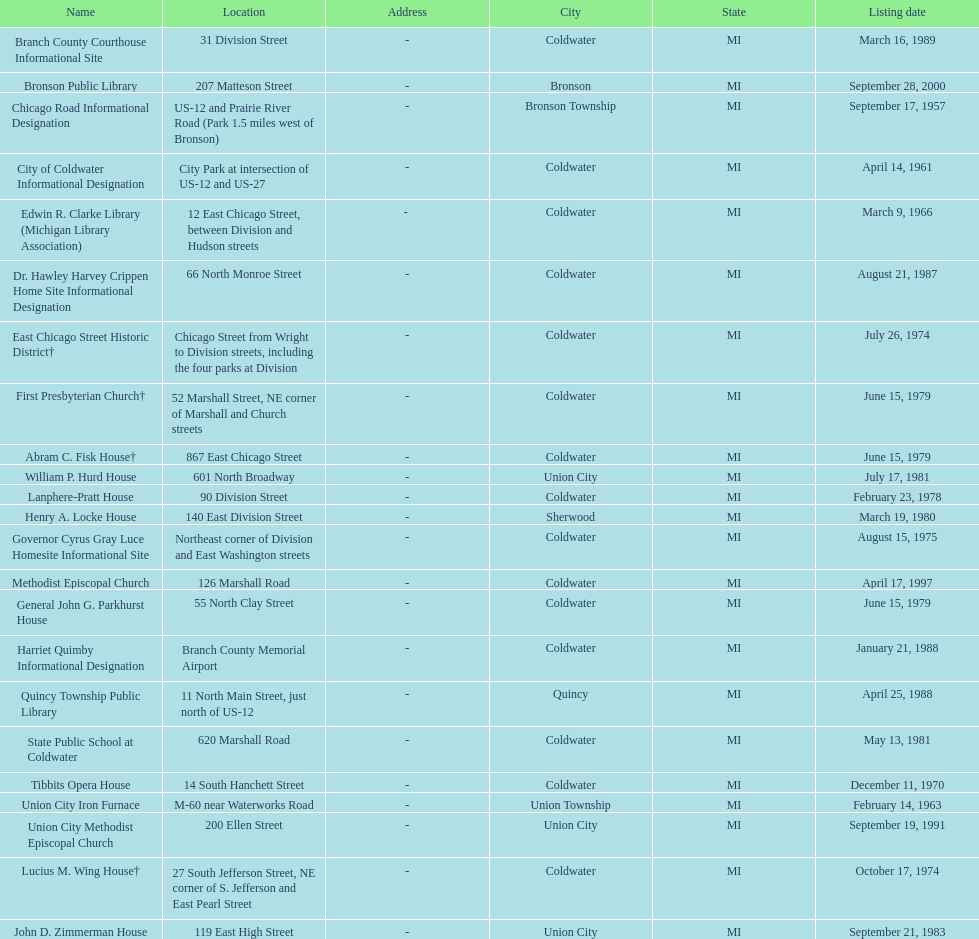How many sites are in coldwater? 15. 